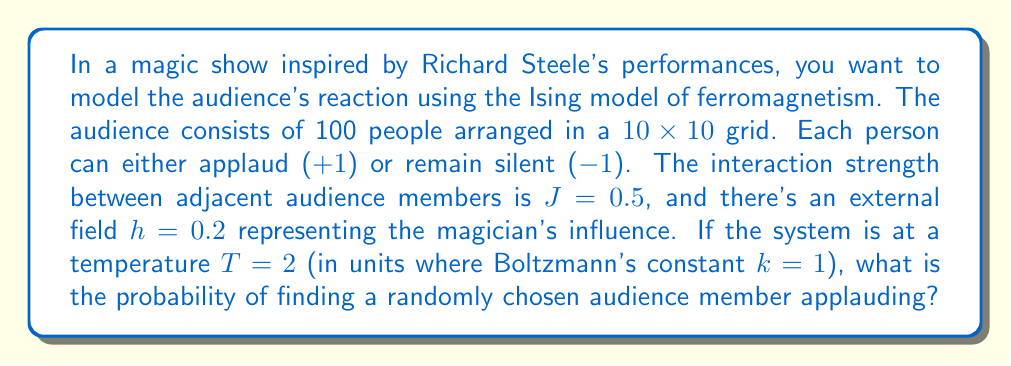Show me your answer to this math problem. To solve this problem, we'll use the mean-field approximation of the Ising model:

1) In the mean-field theory, the magnetization m (average spin) satisfies the self-consistent equation:

   $$m = \tanh(\beta(Jqm + h))$$

   where β = 1/T, q is the number of nearest neighbors, J is the interaction strength, and h is the external field.

2) For a 2D square lattice, q = 4. Given:
   J = 0.5, h = 0.2, T = 2, so β = 1/T = 0.5

3) Substituting these values:

   $$m = \tanh(0.5(4 \cdot 0.5m + 0.2))$$
   $$m = \tanh(m + 0.1)$$

4) This equation can be solved numerically. Using an iterative method or a graphical solution, we find:

   m ≈ 0.3244

5) The magnetization m represents the average spin. In our case:
   P(applaud) = (m + 1) / 2

6) Therefore:
   P(applaud) = (0.3244 + 1) / 2 ≈ 0.6622

So, the probability of finding a randomly chosen audience member applauding is approximately 0.6622 or 66.22%.
Answer: 0.6622 